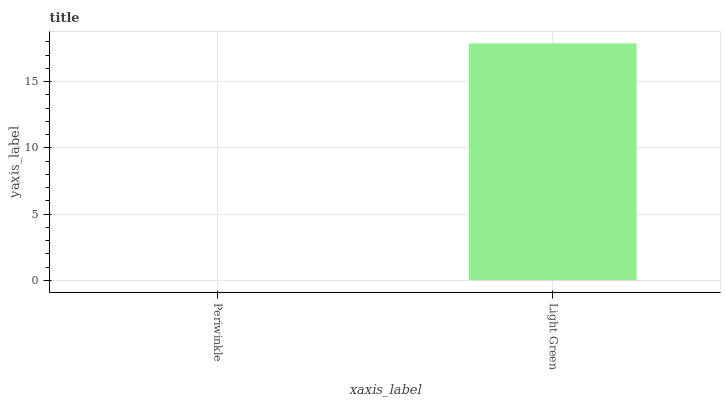Is Periwinkle the minimum?
Answer yes or no. Yes. Is Light Green the maximum?
Answer yes or no. Yes. Is Light Green the minimum?
Answer yes or no. No. Is Light Green greater than Periwinkle?
Answer yes or no. Yes. Is Periwinkle less than Light Green?
Answer yes or no. Yes. Is Periwinkle greater than Light Green?
Answer yes or no. No. Is Light Green less than Periwinkle?
Answer yes or no. No. Is Light Green the high median?
Answer yes or no. Yes. Is Periwinkle the low median?
Answer yes or no. Yes. Is Periwinkle the high median?
Answer yes or no. No. Is Light Green the low median?
Answer yes or no. No. 